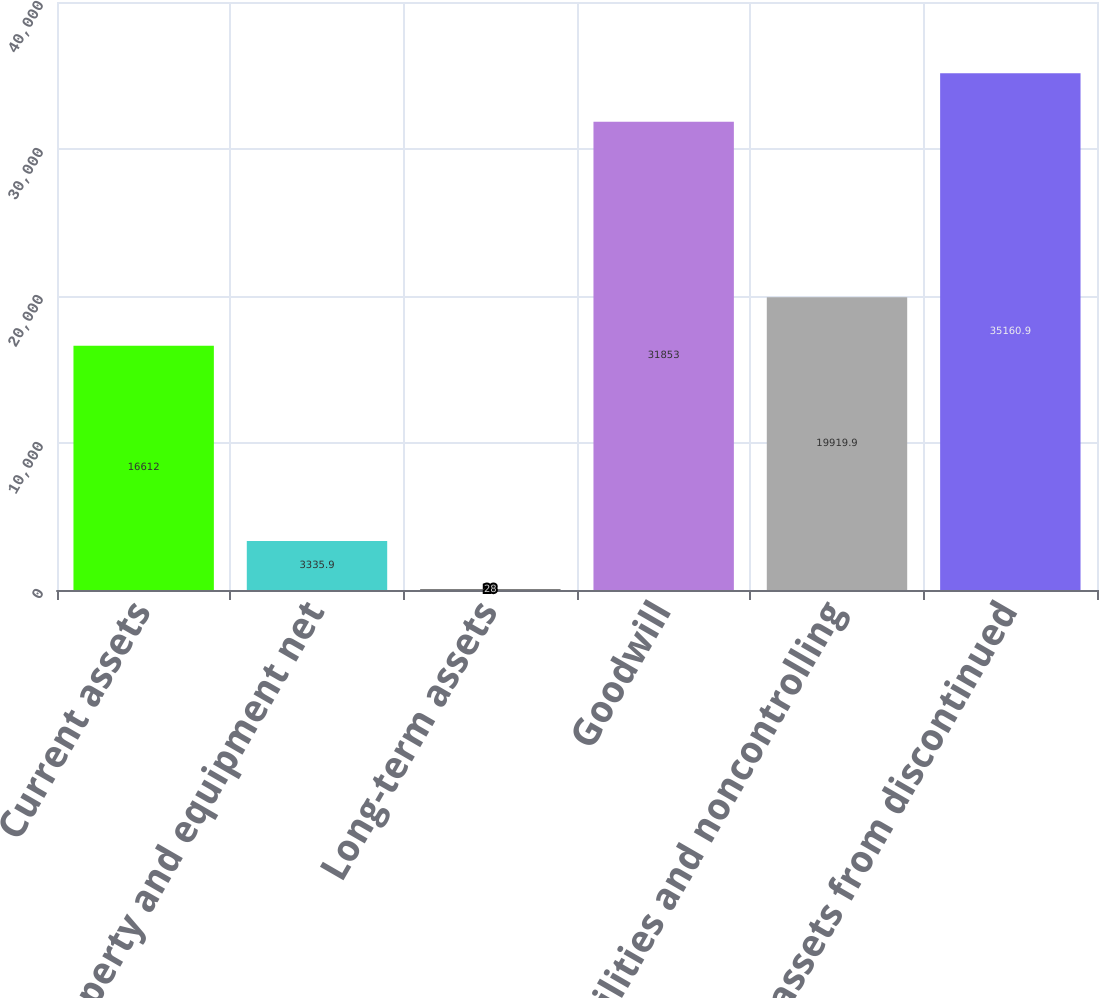Convert chart. <chart><loc_0><loc_0><loc_500><loc_500><bar_chart><fcel>Current assets<fcel>Property and equipment net<fcel>Long-term assets<fcel>Goodwill<fcel>Liabilities and noncontrolling<fcel>Net assets from discontinued<nl><fcel>16612<fcel>3335.9<fcel>28<fcel>31853<fcel>19919.9<fcel>35160.9<nl></chart> 